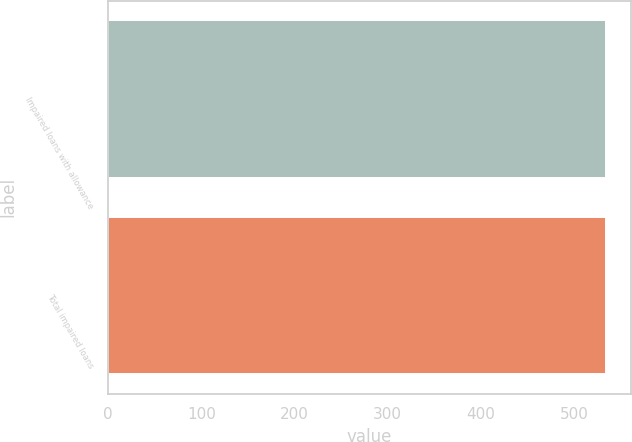Convert chart to OTSL. <chart><loc_0><loc_0><loc_500><loc_500><bar_chart><fcel>Impaired loans with allowance<fcel>Total impaired loans<nl><fcel>534<fcel>534.1<nl></chart> 